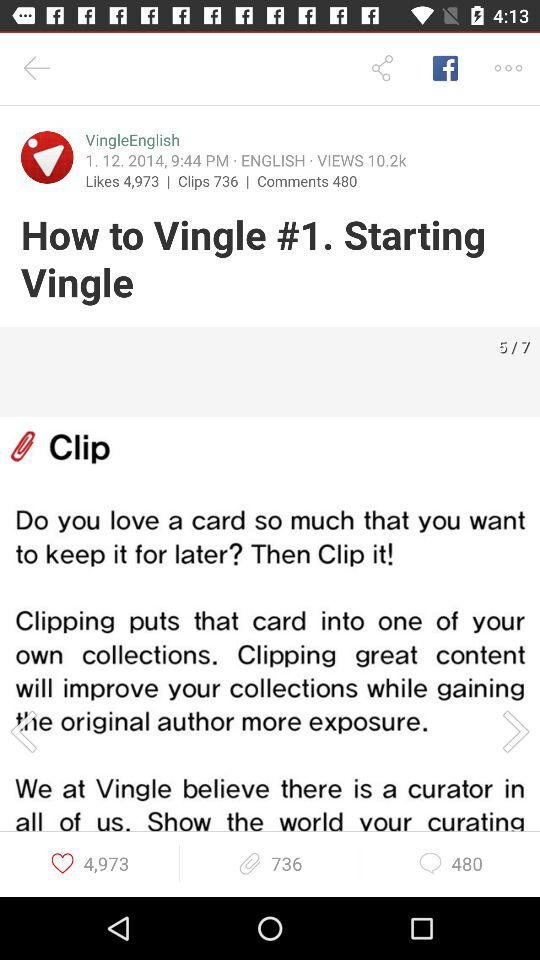How many clips are there? There are 736 clips. 